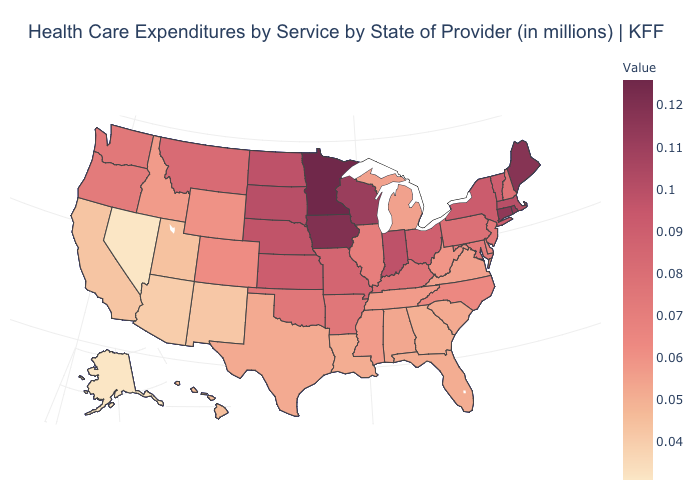Does New Jersey have a higher value than Alaska?
Concise answer only. Yes. Which states have the lowest value in the USA?
Keep it brief. Alaska, Nevada. Does Connecticut have a lower value than Delaware?
Write a very short answer. No. Which states hav the highest value in the West?
Give a very brief answer. Montana. Does Colorado have a higher value than Hawaii?
Keep it brief. Yes. Among the states that border Missouri , which have the lowest value?
Write a very short answer. Tennessee. Is the legend a continuous bar?
Answer briefly. Yes. Does Pennsylvania have the highest value in the Northeast?
Keep it brief. No. Among the states that border Washington , which have the lowest value?
Concise answer only. Idaho. 